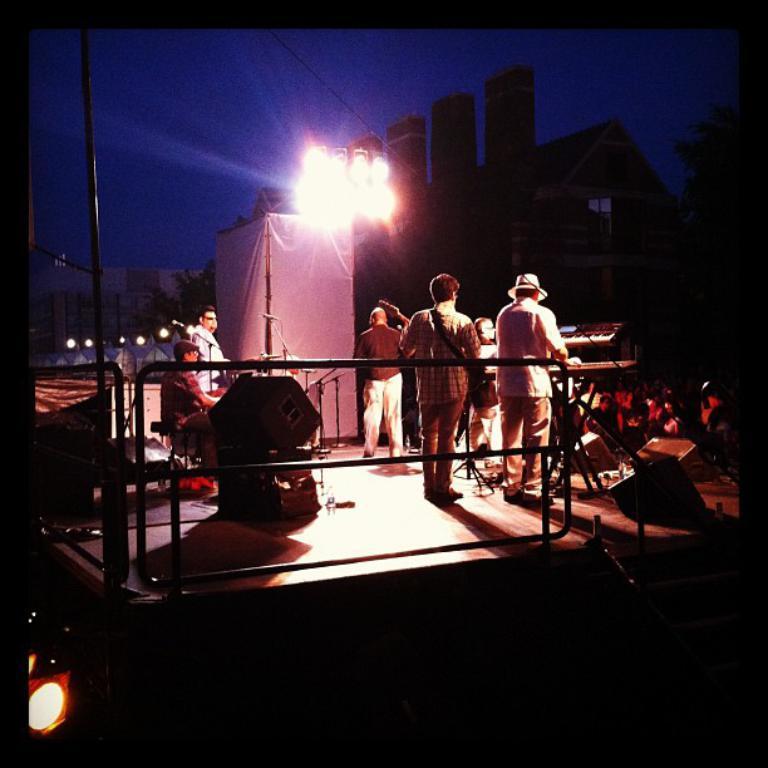Please provide a concise description of this image. I can see the man sitting and playing the drums. These are the speakers. I can see a person standing and holding a guitar. This looks like a show light. Here is a person standing and playing piano. He wore a hat. This looks like a banner. This is the building. I can see a tree. There are group of people standing. 